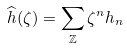<formula> <loc_0><loc_0><loc_500><loc_500>\widehat { h } ( \zeta ) = \sum _ { \mathbb { Z } } \zeta ^ { n } h _ { n }</formula> 